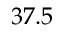<formula> <loc_0><loc_0><loc_500><loc_500>3 7 . 5</formula> 